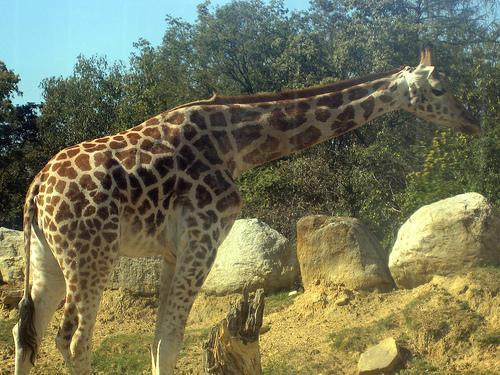How many giraffes are in the photo?
Give a very brief answer. 1. 